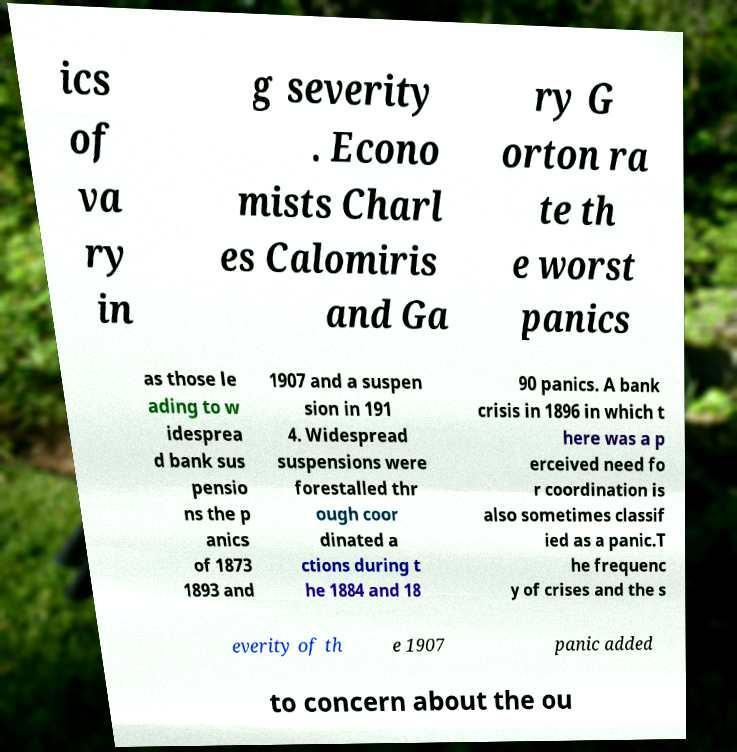Could you extract and type out the text from this image? ics of va ry in g severity . Econo mists Charl es Calomiris and Ga ry G orton ra te th e worst panics as those le ading to w idesprea d bank sus pensio ns the p anics of 1873 1893 and 1907 and a suspen sion in 191 4. Widespread suspensions were forestalled thr ough coor dinated a ctions during t he 1884 and 18 90 panics. A bank crisis in 1896 in which t here was a p erceived need fo r coordination is also sometimes classif ied as a panic.T he frequenc y of crises and the s everity of th e 1907 panic added to concern about the ou 